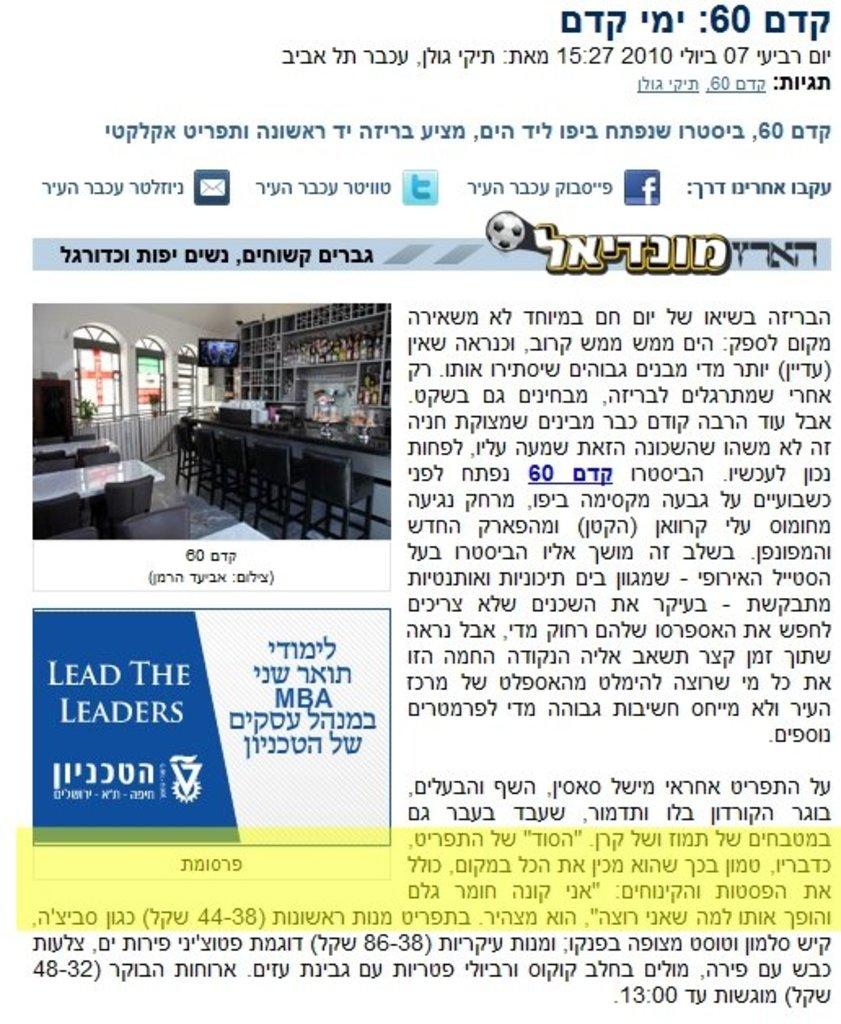What does the ad say?
Offer a terse response. Lead the leaders. What's the number to the top right?
Offer a very short reply. 60. 